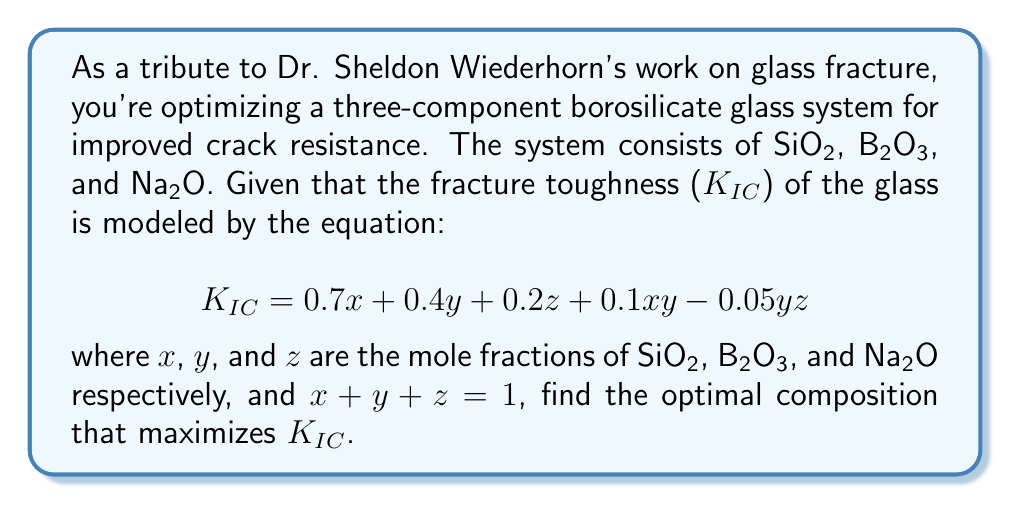Help me with this question. To solve this optimization problem, we'll use the method of Lagrange multipliers:

1) Define the objective function:
   $$f(x,y,z) = 0.7x + 0.4y + 0.2z + 0.1xy - 0.05yz$$

2) Define the constraint:
   $$g(x,y,z) = x + y + z - 1 = 0$$

3) Form the Lagrangian:
   $$L(x,y,z,λ) = f(x,y,z) - λg(x,y,z)$$

4) Take partial derivatives and set them to zero:
   $$\frac{\partial L}{\partial x} = 0.7 + 0.1y - λ = 0$$
   $$\frac{\partial L}{\partial y} = 0.4 + 0.1x - 0.05z - λ = 0$$
   $$\frac{\partial L}{\partial z} = 0.2 - 0.05y - λ = 0$$
   $$\frac{\partial L}{\partial λ} = x + y + z - 1 = 0$$

5) From the first and third equations:
   $$0.7 + 0.1y = 0.2 - 0.05y$$
   $$0.5 = -0.15y$$
   $$y = -\frac{10}{3}$$

   This is impossible as mole fractions must be non-negative.

6) Therefore, the maximum must occur on the boundary. Let's check each edge of the triangle:

   a) If z = 0: 
      $$f(x,y,0) = 0.7x + 0.4y + 0.1xy$$
      $$x + y = 1$$
      Substituting $y = 1-x$:
      $$f(x) = 0.7x + 0.4(1-x) + 0.1x(1-x) = 0.3x + 0.4 + 0.1x - 0.1x^2$$
      $$f'(x) = 0.3 + 0.1 - 0.2x = 0$$
      $$x = 2, y = -1$$ (impossible)

   b) If y = 0:
      $$f(x,0,z) = 0.7x + 0.2z$$
      $$x + z = 1$$
      Clearly, this is maximized when $x = 1, z = 0$

   c) If x = 0:
      $$f(0,y,z) = 0.4y + 0.2z - 0.05yz$$
      $$y + z = 1$$
      Substituting $z = 1-y$:
      $$f(y) = 0.4y + 0.2(1-y) - 0.05y(1-y) = 0.2y + 0.2 + 0.05y^2 - 0.05y$$
      $$f'(y) = 0.2 + 0.1y - 0.05 = 0$$
      $$y = -\frac{3}{2}$$ (impossible)

7) Therefore, the maximum occurs at $x = 1, y = 0, z = 0$.
Answer: 100% SiO₂ 